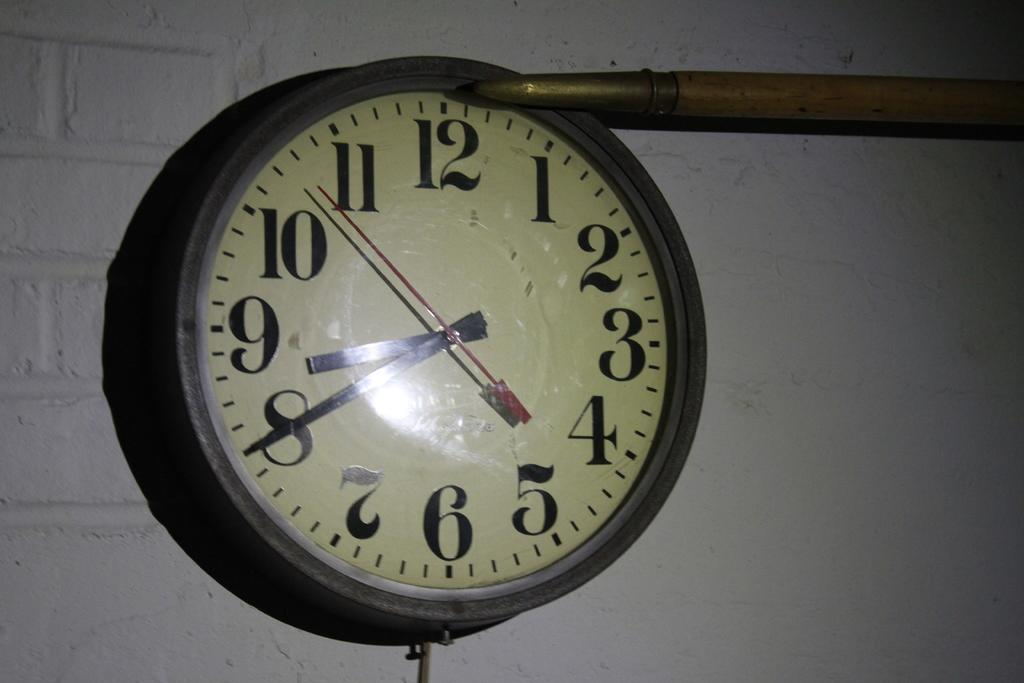<image>
Describe the image concisely. Clock with  a red hand and black hands on the 9 and 8. 